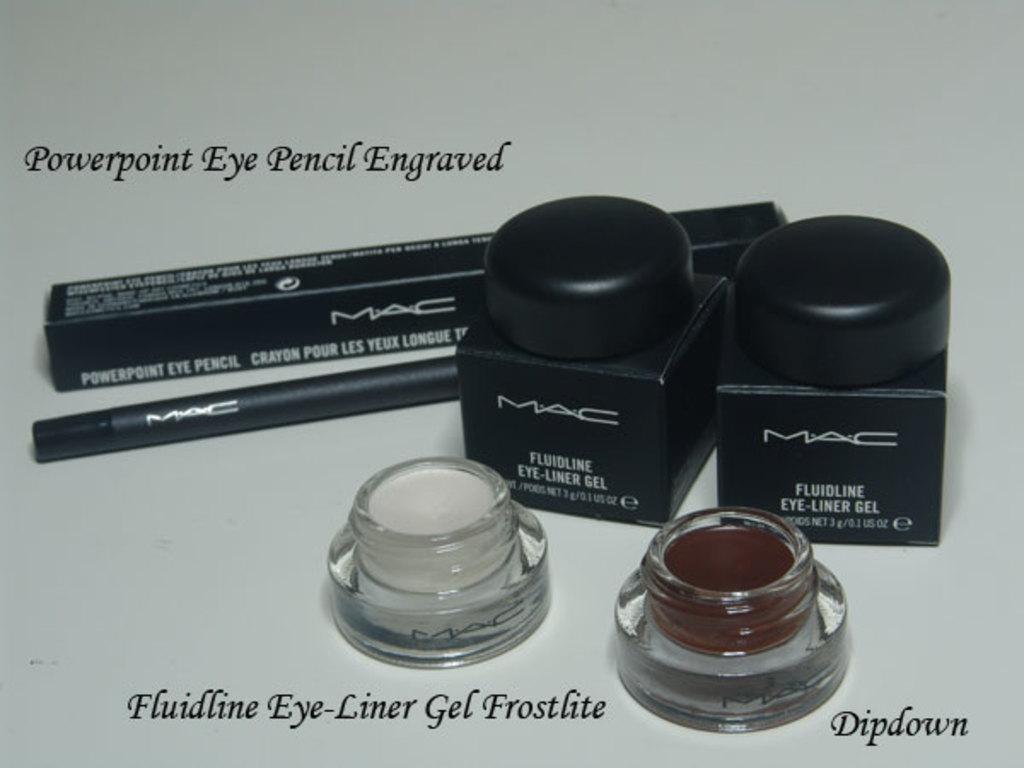<image>
Offer a succinct explanation of the picture presented. Mac make-up being displayed that includes Dipdown and Fluidline Eye Liner Gel Frostlite. 